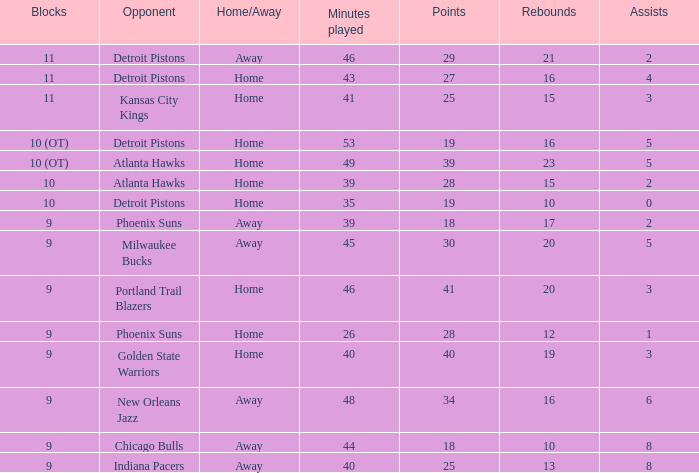How many minutes transpired when there were 18 points and the rival was chicago bulls? 1.0. 